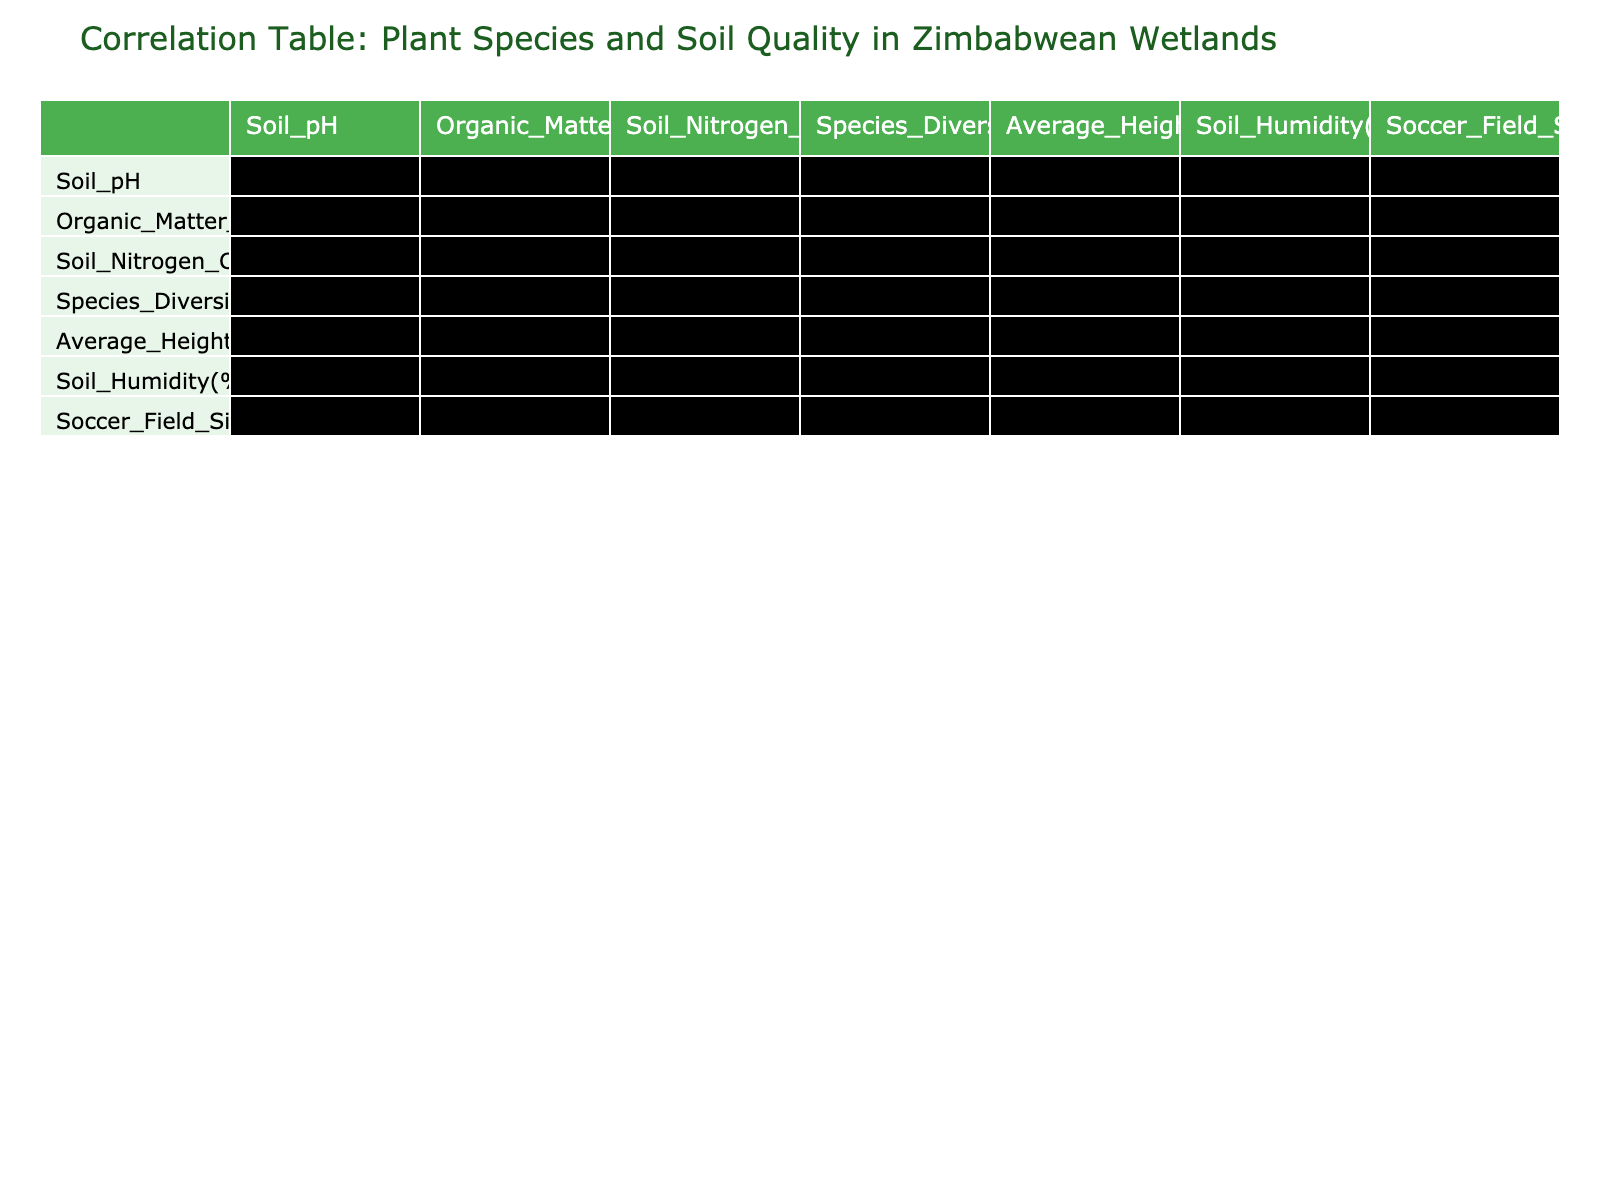What is the species diversity index for "Schoenoplectus tabernaemontani"? The value is found directly in the table under the 'Species Diversity Index' column for "Schoenoplectus tabernaemontani". It shows 3.5.
Answer: 3.5 What is the relationship between soil pH and organic matter content? To find this, look at the correlation value between 'Soil_pH' and 'Organic_Matter_Content'. The table indicates a positive correlation of 0.42.
Answer: 0.42 Is "Nymphaea caerulea" the plant species with the highest average height? Check the 'Average Height' column for each plant species. The highest value listed is 280 cm for "Cyperus papyrus", so "Nymphaea caerulea" does not have the highest average height.
Answer: No Which plant species has the highest soil nitrogen content? Review the 'Soil Nitrogen Content' column and find the maximum value. "Schoenoplectus tabernaemontani" has the highest nitrogen content at 0.35%.
Answer: Schoenoplectus tabernaemontani What is the average species diversity index of all the plant species listed? To calculate the average, sum all species diversity index values (2.8 + 3.2 + 2.5 + 2.0 + 3.0 + 2.2 + 2.3 + 3.5) = 21.5 and divide by 8 (the total number of species), resulting in 21.5 / 8 = 2.6875.
Answer: 2.69 Is there a negative correlation between soil humidity and the species diversity index? Check the correlation value between 'Soil_Humidity' and 'Species_Diversity_Index'. The table shows a correlation of 0.38, indicating a positive relationship, so the statement is false.
Answer: No Which two plant species have the most similar soil pH values? Compare the 'Soil_pH' values for each plant. "Typha domingensis" has a pH of 6.5, and "Echinochloa stagnina" has a pH of 6.4, which are the closest.
Answer: Typha domingensis and Echinochloa stagnina What is the increase in species diversity index from "Phragmites australis" to "Schoenoplectus tabernaemontani"? Find the species diversity index for both plants: "Phragmites australis" has 2.0 and "Schoenoplectus tabernaemontani" has 3.5. The increase is 3.5 - 2.0 = 1.5.
Answer: 1.5 What percentage of organic matter content does "Echinochloa stagnina" have compared to the maximum in the dataset? First, identify the organic matter content for "Echinochloa stagnina", which is 8%, and the maximum is 15% from "Schoenoplectus tabernaemontani". The percentage is (8 / 15) * 100 = 53.33%.
Answer: 53.33% 